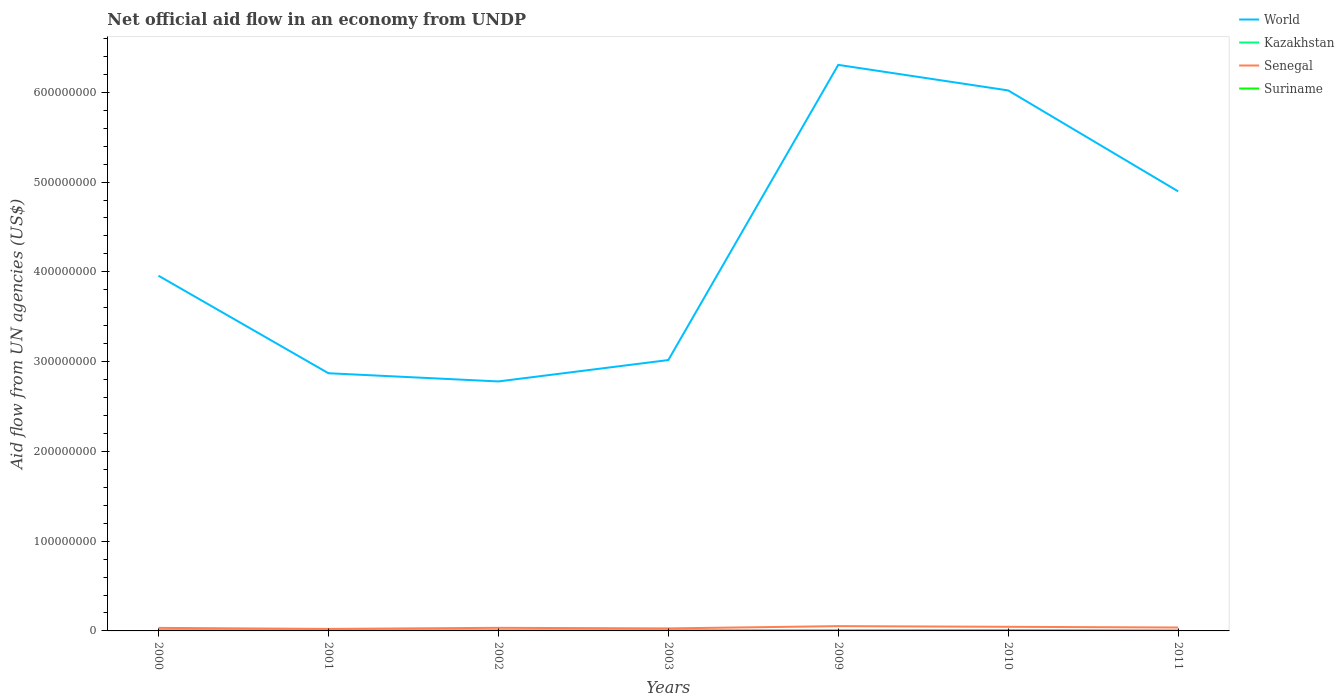In which year was the net official aid flow in Senegal maximum?
Your answer should be compact. 2001. What is the difference between the highest and the second highest net official aid flow in Suriname?
Your answer should be very brief. 4.20e+05. What is the difference between the highest and the lowest net official aid flow in World?
Your answer should be very brief. 3. How many lines are there?
Provide a succinct answer. 4. How many years are there in the graph?
Offer a terse response. 7. What is the difference between two consecutive major ticks on the Y-axis?
Provide a succinct answer. 1.00e+08. Are the values on the major ticks of Y-axis written in scientific E-notation?
Provide a short and direct response. No. Does the graph contain any zero values?
Your answer should be compact. No. How many legend labels are there?
Offer a terse response. 4. How are the legend labels stacked?
Make the answer very short. Vertical. What is the title of the graph?
Provide a succinct answer. Net official aid flow in an economy from UNDP. What is the label or title of the Y-axis?
Offer a very short reply. Aid flow from UN agencies (US$). What is the Aid flow from UN agencies (US$) in World in 2000?
Make the answer very short. 3.96e+08. What is the Aid flow from UN agencies (US$) of Kazakhstan in 2000?
Keep it short and to the point. 8.40e+05. What is the Aid flow from UN agencies (US$) in Senegal in 2000?
Your answer should be compact. 3.37e+06. What is the Aid flow from UN agencies (US$) in Suriname in 2000?
Give a very brief answer. 1.10e+05. What is the Aid flow from UN agencies (US$) of World in 2001?
Your response must be concise. 2.87e+08. What is the Aid flow from UN agencies (US$) in Kazakhstan in 2001?
Keep it short and to the point. 7.90e+05. What is the Aid flow from UN agencies (US$) of Senegal in 2001?
Offer a terse response. 2.25e+06. What is the Aid flow from UN agencies (US$) in World in 2002?
Your answer should be compact. 2.78e+08. What is the Aid flow from UN agencies (US$) in Kazakhstan in 2002?
Provide a succinct answer. 7.30e+05. What is the Aid flow from UN agencies (US$) of Senegal in 2002?
Your answer should be very brief. 3.44e+06. What is the Aid flow from UN agencies (US$) of World in 2003?
Offer a terse response. 3.02e+08. What is the Aid flow from UN agencies (US$) in Kazakhstan in 2003?
Ensure brevity in your answer.  6.40e+05. What is the Aid flow from UN agencies (US$) in Senegal in 2003?
Give a very brief answer. 2.80e+06. What is the Aid flow from UN agencies (US$) in World in 2009?
Make the answer very short. 6.31e+08. What is the Aid flow from UN agencies (US$) of Kazakhstan in 2009?
Make the answer very short. 6.80e+05. What is the Aid flow from UN agencies (US$) of Senegal in 2009?
Keep it short and to the point. 5.32e+06. What is the Aid flow from UN agencies (US$) in Suriname in 2009?
Make the answer very short. 3.20e+05. What is the Aid flow from UN agencies (US$) of World in 2010?
Provide a short and direct response. 6.02e+08. What is the Aid flow from UN agencies (US$) in Kazakhstan in 2010?
Your response must be concise. 8.30e+05. What is the Aid flow from UN agencies (US$) in Senegal in 2010?
Your response must be concise. 4.58e+06. What is the Aid flow from UN agencies (US$) in World in 2011?
Your answer should be very brief. 4.90e+08. What is the Aid flow from UN agencies (US$) in Kazakhstan in 2011?
Keep it short and to the point. 4.50e+05. What is the Aid flow from UN agencies (US$) in Senegal in 2011?
Your answer should be compact. 3.80e+06. What is the Aid flow from UN agencies (US$) in Suriname in 2011?
Ensure brevity in your answer.  2.20e+05. Across all years, what is the maximum Aid flow from UN agencies (US$) in World?
Ensure brevity in your answer.  6.31e+08. Across all years, what is the maximum Aid flow from UN agencies (US$) in Kazakhstan?
Ensure brevity in your answer.  8.40e+05. Across all years, what is the maximum Aid flow from UN agencies (US$) in Senegal?
Keep it short and to the point. 5.32e+06. Across all years, what is the maximum Aid flow from UN agencies (US$) in Suriname?
Offer a very short reply. 4.90e+05. Across all years, what is the minimum Aid flow from UN agencies (US$) of World?
Give a very brief answer. 2.78e+08. Across all years, what is the minimum Aid flow from UN agencies (US$) of Kazakhstan?
Your response must be concise. 4.50e+05. Across all years, what is the minimum Aid flow from UN agencies (US$) of Senegal?
Provide a short and direct response. 2.25e+06. Across all years, what is the minimum Aid flow from UN agencies (US$) of Suriname?
Offer a terse response. 7.00e+04. What is the total Aid flow from UN agencies (US$) of World in the graph?
Keep it short and to the point. 2.98e+09. What is the total Aid flow from UN agencies (US$) in Kazakhstan in the graph?
Offer a very short reply. 4.96e+06. What is the total Aid flow from UN agencies (US$) of Senegal in the graph?
Provide a short and direct response. 2.56e+07. What is the total Aid flow from UN agencies (US$) in Suriname in the graph?
Give a very brief answer. 1.65e+06. What is the difference between the Aid flow from UN agencies (US$) in World in 2000 and that in 2001?
Keep it short and to the point. 1.09e+08. What is the difference between the Aid flow from UN agencies (US$) of Kazakhstan in 2000 and that in 2001?
Give a very brief answer. 5.00e+04. What is the difference between the Aid flow from UN agencies (US$) in Senegal in 2000 and that in 2001?
Make the answer very short. 1.12e+06. What is the difference between the Aid flow from UN agencies (US$) in World in 2000 and that in 2002?
Your response must be concise. 1.18e+08. What is the difference between the Aid flow from UN agencies (US$) of World in 2000 and that in 2003?
Your answer should be compact. 9.40e+07. What is the difference between the Aid flow from UN agencies (US$) in Senegal in 2000 and that in 2003?
Make the answer very short. 5.70e+05. What is the difference between the Aid flow from UN agencies (US$) in World in 2000 and that in 2009?
Provide a succinct answer. -2.35e+08. What is the difference between the Aid flow from UN agencies (US$) of Kazakhstan in 2000 and that in 2009?
Make the answer very short. 1.60e+05. What is the difference between the Aid flow from UN agencies (US$) in Senegal in 2000 and that in 2009?
Your answer should be very brief. -1.95e+06. What is the difference between the Aid flow from UN agencies (US$) of Suriname in 2000 and that in 2009?
Provide a short and direct response. -2.10e+05. What is the difference between the Aid flow from UN agencies (US$) of World in 2000 and that in 2010?
Offer a very short reply. -2.06e+08. What is the difference between the Aid flow from UN agencies (US$) of Senegal in 2000 and that in 2010?
Ensure brevity in your answer.  -1.21e+06. What is the difference between the Aid flow from UN agencies (US$) in Suriname in 2000 and that in 2010?
Provide a succinct answer. -3.80e+05. What is the difference between the Aid flow from UN agencies (US$) in World in 2000 and that in 2011?
Offer a very short reply. -9.40e+07. What is the difference between the Aid flow from UN agencies (US$) of Kazakhstan in 2000 and that in 2011?
Your answer should be compact. 3.90e+05. What is the difference between the Aid flow from UN agencies (US$) in Senegal in 2000 and that in 2011?
Give a very brief answer. -4.30e+05. What is the difference between the Aid flow from UN agencies (US$) of World in 2001 and that in 2002?
Provide a short and direct response. 9.13e+06. What is the difference between the Aid flow from UN agencies (US$) of Senegal in 2001 and that in 2002?
Make the answer very short. -1.19e+06. What is the difference between the Aid flow from UN agencies (US$) of Suriname in 2001 and that in 2002?
Your answer should be very brief. 3.00e+04. What is the difference between the Aid flow from UN agencies (US$) of World in 2001 and that in 2003?
Offer a terse response. -1.47e+07. What is the difference between the Aid flow from UN agencies (US$) in Senegal in 2001 and that in 2003?
Your answer should be very brief. -5.50e+05. What is the difference between the Aid flow from UN agencies (US$) of World in 2001 and that in 2009?
Your answer should be very brief. -3.43e+08. What is the difference between the Aid flow from UN agencies (US$) of Senegal in 2001 and that in 2009?
Your answer should be compact. -3.07e+06. What is the difference between the Aid flow from UN agencies (US$) in Suriname in 2001 and that in 2009?
Provide a short and direct response. -2.20e+05. What is the difference between the Aid flow from UN agencies (US$) in World in 2001 and that in 2010?
Give a very brief answer. -3.15e+08. What is the difference between the Aid flow from UN agencies (US$) of Kazakhstan in 2001 and that in 2010?
Offer a terse response. -4.00e+04. What is the difference between the Aid flow from UN agencies (US$) in Senegal in 2001 and that in 2010?
Provide a short and direct response. -2.33e+06. What is the difference between the Aid flow from UN agencies (US$) of Suriname in 2001 and that in 2010?
Give a very brief answer. -3.90e+05. What is the difference between the Aid flow from UN agencies (US$) in World in 2001 and that in 2011?
Your answer should be compact. -2.03e+08. What is the difference between the Aid flow from UN agencies (US$) of Kazakhstan in 2001 and that in 2011?
Your answer should be compact. 3.40e+05. What is the difference between the Aid flow from UN agencies (US$) of Senegal in 2001 and that in 2011?
Offer a very short reply. -1.55e+06. What is the difference between the Aid flow from UN agencies (US$) in World in 2002 and that in 2003?
Your response must be concise. -2.38e+07. What is the difference between the Aid flow from UN agencies (US$) in Kazakhstan in 2002 and that in 2003?
Your answer should be very brief. 9.00e+04. What is the difference between the Aid flow from UN agencies (US$) of Senegal in 2002 and that in 2003?
Ensure brevity in your answer.  6.40e+05. What is the difference between the Aid flow from UN agencies (US$) of Suriname in 2002 and that in 2003?
Give a very brief answer. -2.70e+05. What is the difference between the Aid flow from UN agencies (US$) of World in 2002 and that in 2009?
Offer a very short reply. -3.53e+08. What is the difference between the Aid flow from UN agencies (US$) of Kazakhstan in 2002 and that in 2009?
Make the answer very short. 5.00e+04. What is the difference between the Aid flow from UN agencies (US$) of Senegal in 2002 and that in 2009?
Ensure brevity in your answer.  -1.88e+06. What is the difference between the Aid flow from UN agencies (US$) of Suriname in 2002 and that in 2009?
Your answer should be compact. -2.50e+05. What is the difference between the Aid flow from UN agencies (US$) of World in 2002 and that in 2010?
Your answer should be very brief. -3.24e+08. What is the difference between the Aid flow from UN agencies (US$) of Senegal in 2002 and that in 2010?
Give a very brief answer. -1.14e+06. What is the difference between the Aid flow from UN agencies (US$) of Suriname in 2002 and that in 2010?
Keep it short and to the point. -4.20e+05. What is the difference between the Aid flow from UN agencies (US$) in World in 2002 and that in 2011?
Provide a short and direct response. -2.12e+08. What is the difference between the Aid flow from UN agencies (US$) in Kazakhstan in 2002 and that in 2011?
Make the answer very short. 2.80e+05. What is the difference between the Aid flow from UN agencies (US$) of Senegal in 2002 and that in 2011?
Make the answer very short. -3.60e+05. What is the difference between the Aid flow from UN agencies (US$) in Suriname in 2002 and that in 2011?
Keep it short and to the point. -1.50e+05. What is the difference between the Aid flow from UN agencies (US$) of World in 2003 and that in 2009?
Keep it short and to the point. -3.29e+08. What is the difference between the Aid flow from UN agencies (US$) in Senegal in 2003 and that in 2009?
Give a very brief answer. -2.52e+06. What is the difference between the Aid flow from UN agencies (US$) in Suriname in 2003 and that in 2009?
Make the answer very short. 2.00e+04. What is the difference between the Aid flow from UN agencies (US$) of World in 2003 and that in 2010?
Provide a succinct answer. -3.00e+08. What is the difference between the Aid flow from UN agencies (US$) in Senegal in 2003 and that in 2010?
Offer a very short reply. -1.78e+06. What is the difference between the Aid flow from UN agencies (US$) in World in 2003 and that in 2011?
Your answer should be very brief. -1.88e+08. What is the difference between the Aid flow from UN agencies (US$) in Kazakhstan in 2003 and that in 2011?
Offer a very short reply. 1.90e+05. What is the difference between the Aid flow from UN agencies (US$) in Suriname in 2003 and that in 2011?
Keep it short and to the point. 1.20e+05. What is the difference between the Aid flow from UN agencies (US$) in World in 2009 and that in 2010?
Offer a very short reply. 2.85e+07. What is the difference between the Aid flow from UN agencies (US$) of Senegal in 2009 and that in 2010?
Your answer should be very brief. 7.40e+05. What is the difference between the Aid flow from UN agencies (US$) of Suriname in 2009 and that in 2010?
Your answer should be compact. -1.70e+05. What is the difference between the Aid flow from UN agencies (US$) in World in 2009 and that in 2011?
Provide a short and direct response. 1.41e+08. What is the difference between the Aid flow from UN agencies (US$) of Kazakhstan in 2009 and that in 2011?
Your answer should be compact. 2.30e+05. What is the difference between the Aid flow from UN agencies (US$) in Senegal in 2009 and that in 2011?
Make the answer very short. 1.52e+06. What is the difference between the Aid flow from UN agencies (US$) in Suriname in 2009 and that in 2011?
Give a very brief answer. 1.00e+05. What is the difference between the Aid flow from UN agencies (US$) in World in 2010 and that in 2011?
Provide a short and direct response. 1.12e+08. What is the difference between the Aid flow from UN agencies (US$) in Senegal in 2010 and that in 2011?
Provide a succinct answer. 7.80e+05. What is the difference between the Aid flow from UN agencies (US$) of Suriname in 2010 and that in 2011?
Your response must be concise. 2.70e+05. What is the difference between the Aid flow from UN agencies (US$) of World in 2000 and the Aid flow from UN agencies (US$) of Kazakhstan in 2001?
Keep it short and to the point. 3.95e+08. What is the difference between the Aid flow from UN agencies (US$) of World in 2000 and the Aid flow from UN agencies (US$) of Senegal in 2001?
Offer a terse response. 3.93e+08. What is the difference between the Aid flow from UN agencies (US$) in World in 2000 and the Aid flow from UN agencies (US$) in Suriname in 2001?
Offer a terse response. 3.96e+08. What is the difference between the Aid flow from UN agencies (US$) in Kazakhstan in 2000 and the Aid flow from UN agencies (US$) in Senegal in 2001?
Make the answer very short. -1.41e+06. What is the difference between the Aid flow from UN agencies (US$) of Kazakhstan in 2000 and the Aid flow from UN agencies (US$) of Suriname in 2001?
Your response must be concise. 7.40e+05. What is the difference between the Aid flow from UN agencies (US$) in Senegal in 2000 and the Aid flow from UN agencies (US$) in Suriname in 2001?
Give a very brief answer. 3.27e+06. What is the difference between the Aid flow from UN agencies (US$) of World in 2000 and the Aid flow from UN agencies (US$) of Kazakhstan in 2002?
Make the answer very short. 3.95e+08. What is the difference between the Aid flow from UN agencies (US$) in World in 2000 and the Aid flow from UN agencies (US$) in Senegal in 2002?
Offer a very short reply. 3.92e+08. What is the difference between the Aid flow from UN agencies (US$) in World in 2000 and the Aid flow from UN agencies (US$) in Suriname in 2002?
Ensure brevity in your answer.  3.96e+08. What is the difference between the Aid flow from UN agencies (US$) in Kazakhstan in 2000 and the Aid flow from UN agencies (US$) in Senegal in 2002?
Your answer should be compact. -2.60e+06. What is the difference between the Aid flow from UN agencies (US$) of Kazakhstan in 2000 and the Aid flow from UN agencies (US$) of Suriname in 2002?
Offer a terse response. 7.70e+05. What is the difference between the Aid flow from UN agencies (US$) in Senegal in 2000 and the Aid flow from UN agencies (US$) in Suriname in 2002?
Make the answer very short. 3.30e+06. What is the difference between the Aid flow from UN agencies (US$) in World in 2000 and the Aid flow from UN agencies (US$) in Kazakhstan in 2003?
Provide a short and direct response. 3.95e+08. What is the difference between the Aid flow from UN agencies (US$) in World in 2000 and the Aid flow from UN agencies (US$) in Senegal in 2003?
Offer a very short reply. 3.93e+08. What is the difference between the Aid flow from UN agencies (US$) in World in 2000 and the Aid flow from UN agencies (US$) in Suriname in 2003?
Provide a succinct answer. 3.95e+08. What is the difference between the Aid flow from UN agencies (US$) in Kazakhstan in 2000 and the Aid flow from UN agencies (US$) in Senegal in 2003?
Provide a short and direct response. -1.96e+06. What is the difference between the Aid flow from UN agencies (US$) of Senegal in 2000 and the Aid flow from UN agencies (US$) of Suriname in 2003?
Give a very brief answer. 3.03e+06. What is the difference between the Aid flow from UN agencies (US$) of World in 2000 and the Aid flow from UN agencies (US$) of Kazakhstan in 2009?
Your answer should be very brief. 3.95e+08. What is the difference between the Aid flow from UN agencies (US$) of World in 2000 and the Aid flow from UN agencies (US$) of Senegal in 2009?
Your answer should be compact. 3.90e+08. What is the difference between the Aid flow from UN agencies (US$) of World in 2000 and the Aid flow from UN agencies (US$) of Suriname in 2009?
Ensure brevity in your answer.  3.95e+08. What is the difference between the Aid flow from UN agencies (US$) of Kazakhstan in 2000 and the Aid flow from UN agencies (US$) of Senegal in 2009?
Make the answer very short. -4.48e+06. What is the difference between the Aid flow from UN agencies (US$) of Kazakhstan in 2000 and the Aid flow from UN agencies (US$) of Suriname in 2009?
Provide a short and direct response. 5.20e+05. What is the difference between the Aid flow from UN agencies (US$) in Senegal in 2000 and the Aid flow from UN agencies (US$) in Suriname in 2009?
Offer a terse response. 3.05e+06. What is the difference between the Aid flow from UN agencies (US$) in World in 2000 and the Aid flow from UN agencies (US$) in Kazakhstan in 2010?
Your answer should be compact. 3.95e+08. What is the difference between the Aid flow from UN agencies (US$) of World in 2000 and the Aid flow from UN agencies (US$) of Senegal in 2010?
Your answer should be very brief. 3.91e+08. What is the difference between the Aid flow from UN agencies (US$) of World in 2000 and the Aid flow from UN agencies (US$) of Suriname in 2010?
Your response must be concise. 3.95e+08. What is the difference between the Aid flow from UN agencies (US$) of Kazakhstan in 2000 and the Aid flow from UN agencies (US$) of Senegal in 2010?
Your response must be concise. -3.74e+06. What is the difference between the Aid flow from UN agencies (US$) of Senegal in 2000 and the Aid flow from UN agencies (US$) of Suriname in 2010?
Offer a very short reply. 2.88e+06. What is the difference between the Aid flow from UN agencies (US$) of World in 2000 and the Aid flow from UN agencies (US$) of Kazakhstan in 2011?
Offer a terse response. 3.95e+08. What is the difference between the Aid flow from UN agencies (US$) in World in 2000 and the Aid flow from UN agencies (US$) in Senegal in 2011?
Provide a short and direct response. 3.92e+08. What is the difference between the Aid flow from UN agencies (US$) in World in 2000 and the Aid flow from UN agencies (US$) in Suriname in 2011?
Your response must be concise. 3.95e+08. What is the difference between the Aid flow from UN agencies (US$) of Kazakhstan in 2000 and the Aid flow from UN agencies (US$) of Senegal in 2011?
Ensure brevity in your answer.  -2.96e+06. What is the difference between the Aid flow from UN agencies (US$) in Kazakhstan in 2000 and the Aid flow from UN agencies (US$) in Suriname in 2011?
Your response must be concise. 6.20e+05. What is the difference between the Aid flow from UN agencies (US$) in Senegal in 2000 and the Aid flow from UN agencies (US$) in Suriname in 2011?
Provide a succinct answer. 3.15e+06. What is the difference between the Aid flow from UN agencies (US$) in World in 2001 and the Aid flow from UN agencies (US$) in Kazakhstan in 2002?
Give a very brief answer. 2.86e+08. What is the difference between the Aid flow from UN agencies (US$) in World in 2001 and the Aid flow from UN agencies (US$) in Senegal in 2002?
Keep it short and to the point. 2.84e+08. What is the difference between the Aid flow from UN agencies (US$) in World in 2001 and the Aid flow from UN agencies (US$) in Suriname in 2002?
Give a very brief answer. 2.87e+08. What is the difference between the Aid flow from UN agencies (US$) of Kazakhstan in 2001 and the Aid flow from UN agencies (US$) of Senegal in 2002?
Offer a very short reply. -2.65e+06. What is the difference between the Aid flow from UN agencies (US$) in Kazakhstan in 2001 and the Aid flow from UN agencies (US$) in Suriname in 2002?
Your answer should be compact. 7.20e+05. What is the difference between the Aid flow from UN agencies (US$) of Senegal in 2001 and the Aid flow from UN agencies (US$) of Suriname in 2002?
Provide a short and direct response. 2.18e+06. What is the difference between the Aid flow from UN agencies (US$) in World in 2001 and the Aid flow from UN agencies (US$) in Kazakhstan in 2003?
Provide a succinct answer. 2.86e+08. What is the difference between the Aid flow from UN agencies (US$) of World in 2001 and the Aid flow from UN agencies (US$) of Senegal in 2003?
Your response must be concise. 2.84e+08. What is the difference between the Aid flow from UN agencies (US$) of World in 2001 and the Aid flow from UN agencies (US$) of Suriname in 2003?
Ensure brevity in your answer.  2.87e+08. What is the difference between the Aid flow from UN agencies (US$) in Kazakhstan in 2001 and the Aid flow from UN agencies (US$) in Senegal in 2003?
Offer a terse response. -2.01e+06. What is the difference between the Aid flow from UN agencies (US$) in Senegal in 2001 and the Aid flow from UN agencies (US$) in Suriname in 2003?
Ensure brevity in your answer.  1.91e+06. What is the difference between the Aid flow from UN agencies (US$) of World in 2001 and the Aid flow from UN agencies (US$) of Kazakhstan in 2009?
Ensure brevity in your answer.  2.86e+08. What is the difference between the Aid flow from UN agencies (US$) in World in 2001 and the Aid flow from UN agencies (US$) in Senegal in 2009?
Your answer should be very brief. 2.82e+08. What is the difference between the Aid flow from UN agencies (US$) of World in 2001 and the Aid flow from UN agencies (US$) of Suriname in 2009?
Keep it short and to the point. 2.87e+08. What is the difference between the Aid flow from UN agencies (US$) of Kazakhstan in 2001 and the Aid flow from UN agencies (US$) of Senegal in 2009?
Ensure brevity in your answer.  -4.53e+06. What is the difference between the Aid flow from UN agencies (US$) of Kazakhstan in 2001 and the Aid flow from UN agencies (US$) of Suriname in 2009?
Keep it short and to the point. 4.70e+05. What is the difference between the Aid flow from UN agencies (US$) in Senegal in 2001 and the Aid flow from UN agencies (US$) in Suriname in 2009?
Make the answer very short. 1.93e+06. What is the difference between the Aid flow from UN agencies (US$) of World in 2001 and the Aid flow from UN agencies (US$) of Kazakhstan in 2010?
Provide a succinct answer. 2.86e+08. What is the difference between the Aid flow from UN agencies (US$) in World in 2001 and the Aid flow from UN agencies (US$) in Senegal in 2010?
Provide a short and direct response. 2.82e+08. What is the difference between the Aid flow from UN agencies (US$) in World in 2001 and the Aid flow from UN agencies (US$) in Suriname in 2010?
Provide a succinct answer. 2.87e+08. What is the difference between the Aid flow from UN agencies (US$) in Kazakhstan in 2001 and the Aid flow from UN agencies (US$) in Senegal in 2010?
Keep it short and to the point. -3.79e+06. What is the difference between the Aid flow from UN agencies (US$) in Senegal in 2001 and the Aid flow from UN agencies (US$) in Suriname in 2010?
Ensure brevity in your answer.  1.76e+06. What is the difference between the Aid flow from UN agencies (US$) of World in 2001 and the Aid flow from UN agencies (US$) of Kazakhstan in 2011?
Give a very brief answer. 2.87e+08. What is the difference between the Aid flow from UN agencies (US$) of World in 2001 and the Aid flow from UN agencies (US$) of Senegal in 2011?
Make the answer very short. 2.83e+08. What is the difference between the Aid flow from UN agencies (US$) of World in 2001 and the Aid flow from UN agencies (US$) of Suriname in 2011?
Keep it short and to the point. 2.87e+08. What is the difference between the Aid flow from UN agencies (US$) of Kazakhstan in 2001 and the Aid flow from UN agencies (US$) of Senegal in 2011?
Provide a succinct answer. -3.01e+06. What is the difference between the Aid flow from UN agencies (US$) of Kazakhstan in 2001 and the Aid flow from UN agencies (US$) of Suriname in 2011?
Your response must be concise. 5.70e+05. What is the difference between the Aid flow from UN agencies (US$) of Senegal in 2001 and the Aid flow from UN agencies (US$) of Suriname in 2011?
Your answer should be very brief. 2.03e+06. What is the difference between the Aid flow from UN agencies (US$) of World in 2002 and the Aid flow from UN agencies (US$) of Kazakhstan in 2003?
Ensure brevity in your answer.  2.77e+08. What is the difference between the Aid flow from UN agencies (US$) in World in 2002 and the Aid flow from UN agencies (US$) in Senegal in 2003?
Provide a short and direct response. 2.75e+08. What is the difference between the Aid flow from UN agencies (US$) in World in 2002 and the Aid flow from UN agencies (US$) in Suriname in 2003?
Offer a terse response. 2.78e+08. What is the difference between the Aid flow from UN agencies (US$) in Kazakhstan in 2002 and the Aid flow from UN agencies (US$) in Senegal in 2003?
Your answer should be very brief. -2.07e+06. What is the difference between the Aid flow from UN agencies (US$) in Senegal in 2002 and the Aid flow from UN agencies (US$) in Suriname in 2003?
Make the answer very short. 3.10e+06. What is the difference between the Aid flow from UN agencies (US$) in World in 2002 and the Aid flow from UN agencies (US$) in Kazakhstan in 2009?
Keep it short and to the point. 2.77e+08. What is the difference between the Aid flow from UN agencies (US$) in World in 2002 and the Aid flow from UN agencies (US$) in Senegal in 2009?
Give a very brief answer. 2.73e+08. What is the difference between the Aid flow from UN agencies (US$) of World in 2002 and the Aid flow from UN agencies (US$) of Suriname in 2009?
Make the answer very short. 2.78e+08. What is the difference between the Aid flow from UN agencies (US$) in Kazakhstan in 2002 and the Aid flow from UN agencies (US$) in Senegal in 2009?
Your response must be concise. -4.59e+06. What is the difference between the Aid flow from UN agencies (US$) in Kazakhstan in 2002 and the Aid flow from UN agencies (US$) in Suriname in 2009?
Keep it short and to the point. 4.10e+05. What is the difference between the Aid flow from UN agencies (US$) of Senegal in 2002 and the Aid flow from UN agencies (US$) of Suriname in 2009?
Your response must be concise. 3.12e+06. What is the difference between the Aid flow from UN agencies (US$) of World in 2002 and the Aid flow from UN agencies (US$) of Kazakhstan in 2010?
Your response must be concise. 2.77e+08. What is the difference between the Aid flow from UN agencies (US$) of World in 2002 and the Aid flow from UN agencies (US$) of Senegal in 2010?
Make the answer very short. 2.73e+08. What is the difference between the Aid flow from UN agencies (US$) in World in 2002 and the Aid flow from UN agencies (US$) in Suriname in 2010?
Ensure brevity in your answer.  2.77e+08. What is the difference between the Aid flow from UN agencies (US$) in Kazakhstan in 2002 and the Aid flow from UN agencies (US$) in Senegal in 2010?
Provide a succinct answer. -3.85e+06. What is the difference between the Aid flow from UN agencies (US$) in Senegal in 2002 and the Aid flow from UN agencies (US$) in Suriname in 2010?
Your response must be concise. 2.95e+06. What is the difference between the Aid flow from UN agencies (US$) in World in 2002 and the Aid flow from UN agencies (US$) in Kazakhstan in 2011?
Your response must be concise. 2.77e+08. What is the difference between the Aid flow from UN agencies (US$) in World in 2002 and the Aid flow from UN agencies (US$) in Senegal in 2011?
Ensure brevity in your answer.  2.74e+08. What is the difference between the Aid flow from UN agencies (US$) in World in 2002 and the Aid flow from UN agencies (US$) in Suriname in 2011?
Make the answer very short. 2.78e+08. What is the difference between the Aid flow from UN agencies (US$) of Kazakhstan in 2002 and the Aid flow from UN agencies (US$) of Senegal in 2011?
Keep it short and to the point. -3.07e+06. What is the difference between the Aid flow from UN agencies (US$) in Kazakhstan in 2002 and the Aid flow from UN agencies (US$) in Suriname in 2011?
Provide a short and direct response. 5.10e+05. What is the difference between the Aid flow from UN agencies (US$) of Senegal in 2002 and the Aid flow from UN agencies (US$) of Suriname in 2011?
Offer a very short reply. 3.22e+06. What is the difference between the Aid flow from UN agencies (US$) of World in 2003 and the Aid flow from UN agencies (US$) of Kazakhstan in 2009?
Provide a short and direct response. 3.01e+08. What is the difference between the Aid flow from UN agencies (US$) of World in 2003 and the Aid flow from UN agencies (US$) of Senegal in 2009?
Ensure brevity in your answer.  2.96e+08. What is the difference between the Aid flow from UN agencies (US$) of World in 2003 and the Aid flow from UN agencies (US$) of Suriname in 2009?
Make the answer very short. 3.01e+08. What is the difference between the Aid flow from UN agencies (US$) of Kazakhstan in 2003 and the Aid flow from UN agencies (US$) of Senegal in 2009?
Your answer should be compact. -4.68e+06. What is the difference between the Aid flow from UN agencies (US$) in Kazakhstan in 2003 and the Aid flow from UN agencies (US$) in Suriname in 2009?
Provide a succinct answer. 3.20e+05. What is the difference between the Aid flow from UN agencies (US$) of Senegal in 2003 and the Aid flow from UN agencies (US$) of Suriname in 2009?
Provide a succinct answer. 2.48e+06. What is the difference between the Aid flow from UN agencies (US$) of World in 2003 and the Aid flow from UN agencies (US$) of Kazakhstan in 2010?
Your response must be concise. 3.01e+08. What is the difference between the Aid flow from UN agencies (US$) of World in 2003 and the Aid flow from UN agencies (US$) of Senegal in 2010?
Keep it short and to the point. 2.97e+08. What is the difference between the Aid flow from UN agencies (US$) in World in 2003 and the Aid flow from UN agencies (US$) in Suriname in 2010?
Provide a short and direct response. 3.01e+08. What is the difference between the Aid flow from UN agencies (US$) in Kazakhstan in 2003 and the Aid flow from UN agencies (US$) in Senegal in 2010?
Offer a very short reply. -3.94e+06. What is the difference between the Aid flow from UN agencies (US$) of Kazakhstan in 2003 and the Aid flow from UN agencies (US$) of Suriname in 2010?
Make the answer very short. 1.50e+05. What is the difference between the Aid flow from UN agencies (US$) in Senegal in 2003 and the Aid flow from UN agencies (US$) in Suriname in 2010?
Provide a succinct answer. 2.31e+06. What is the difference between the Aid flow from UN agencies (US$) in World in 2003 and the Aid flow from UN agencies (US$) in Kazakhstan in 2011?
Your answer should be compact. 3.01e+08. What is the difference between the Aid flow from UN agencies (US$) in World in 2003 and the Aid flow from UN agencies (US$) in Senegal in 2011?
Make the answer very short. 2.98e+08. What is the difference between the Aid flow from UN agencies (US$) in World in 2003 and the Aid flow from UN agencies (US$) in Suriname in 2011?
Your response must be concise. 3.02e+08. What is the difference between the Aid flow from UN agencies (US$) in Kazakhstan in 2003 and the Aid flow from UN agencies (US$) in Senegal in 2011?
Your answer should be very brief. -3.16e+06. What is the difference between the Aid flow from UN agencies (US$) of Kazakhstan in 2003 and the Aid flow from UN agencies (US$) of Suriname in 2011?
Your response must be concise. 4.20e+05. What is the difference between the Aid flow from UN agencies (US$) in Senegal in 2003 and the Aid flow from UN agencies (US$) in Suriname in 2011?
Offer a terse response. 2.58e+06. What is the difference between the Aid flow from UN agencies (US$) in World in 2009 and the Aid flow from UN agencies (US$) in Kazakhstan in 2010?
Ensure brevity in your answer.  6.30e+08. What is the difference between the Aid flow from UN agencies (US$) in World in 2009 and the Aid flow from UN agencies (US$) in Senegal in 2010?
Provide a succinct answer. 6.26e+08. What is the difference between the Aid flow from UN agencies (US$) of World in 2009 and the Aid flow from UN agencies (US$) of Suriname in 2010?
Offer a terse response. 6.30e+08. What is the difference between the Aid flow from UN agencies (US$) in Kazakhstan in 2009 and the Aid flow from UN agencies (US$) in Senegal in 2010?
Make the answer very short. -3.90e+06. What is the difference between the Aid flow from UN agencies (US$) of Senegal in 2009 and the Aid flow from UN agencies (US$) of Suriname in 2010?
Offer a terse response. 4.83e+06. What is the difference between the Aid flow from UN agencies (US$) in World in 2009 and the Aid flow from UN agencies (US$) in Kazakhstan in 2011?
Provide a short and direct response. 6.30e+08. What is the difference between the Aid flow from UN agencies (US$) in World in 2009 and the Aid flow from UN agencies (US$) in Senegal in 2011?
Keep it short and to the point. 6.27e+08. What is the difference between the Aid flow from UN agencies (US$) of World in 2009 and the Aid flow from UN agencies (US$) of Suriname in 2011?
Your answer should be very brief. 6.30e+08. What is the difference between the Aid flow from UN agencies (US$) of Kazakhstan in 2009 and the Aid flow from UN agencies (US$) of Senegal in 2011?
Ensure brevity in your answer.  -3.12e+06. What is the difference between the Aid flow from UN agencies (US$) in Senegal in 2009 and the Aid flow from UN agencies (US$) in Suriname in 2011?
Your answer should be compact. 5.10e+06. What is the difference between the Aid flow from UN agencies (US$) of World in 2010 and the Aid flow from UN agencies (US$) of Kazakhstan in 2011?
Keep it short and to the point. 6.02e+08. What is the difference between the Aid flow from UN agencies (US$) of World in 2010 and the Aid flow from UN agencies (US$) of Senegal in 2011?
Offer a terse response. 5.98e+08. What is the difference between the Aid flow from UN agencies (US$) of World in 2010 and the Aid flow from UN agencies (US$) of Suriname in 2011?
Your answer should be compact. 6.02e+08. What is the difference between the Aid flow from UN agencies (US$) of Kazakhstan in 2010 and the Aid flow from UN agencies (US$) of Senegal in 2011?
Offer a terse response. -2.97e+06. What is the difference between the Aid flow from UN agencies (US$) in Senegal in 2010 and the Aid flow from UN agencies (US$) in Suriname in 2011?
Make the answer very short. 4.36e+06. What is the average Aid flow from UN agencies (US$) of World per year?
Your answer should be very brief. 4.26e+08. What is the average Aid flow from UN agencies (US$) of Kazakhstan per year?
Make the answer very short. 7.09e+05. What is the average Aid flow from UN agencies (US$) in Senegal per year?
Your answer should be very brief. 3.65e+06. What is the average Aid flow from UN agencies (US$) of Suriname per year?
Offer a terse response. 2.36e+05. In the year 2000, what is the difference between the Aid flow from UN agencies (US$) in World and Aid flow from UN agencies (US$) in Kazakhstan?
Your answer should be compact. 3.95e+08. In the year 2000, what is the difference between the Aid flow from UN agencies (US$) of World and Aid flow from UN agencies (US$) of Senegal?
Make the answer very short. 3.92e+08. In the year 2000, what is the difference between the Aid flow from UN agencies (US$) of World and Aid flow from UN agencies (US$) of Suriname?
Provide a succinct answer. 3.96e+08. In the year 2000, what is the difference between the Aid flow from UN agencies (US$) in Kazakhstan and Aid flow from UN agencies (US$) in Senegal?
Make the answer very short. -2.53e+06. In the year 2000, what is the difference between the Aid flow from UN agencies (US$) of Kazakhstan and Aid flow from UN agencies (US$) of Suriname?
Your answer should be compact. 7.30e+05. In the year 2000, what is the difference between the Aid flow from UN agencies (US$) of Senegal and Aid flow from UN agencies (US$) of Suriname?
Keep it short and to the point. 3.26e+06. In the year 2001, what is the difference between the Aid flow from UN agencies (US$) in World and Aid flow from UN agencies (US$) in Kazakhstan?
Offer a very short reply. 2.86e+08. In the year 2001, what is the difference between the Aid flow from UN agencies (US$) of World and Aid flow from UN agencies (US$) of Senegal?
Offer a very short reply. 2.85e+08. In the year 2001, what is the difference between the Aid flow from UN agencies (US$) of World and Aid flow from UN agencies (US$) of Suriname?
Your answer should be compact. 2.87e+08. In the year 2001, what is the difference between the Aid flow from UN agencies (US$) of Kazakhstan and Aid flow from UN agencies (US$) of Senegal?
Your response must be concise. -1.46e+06. In the year 2001, what is the difference between the Aid flow from UN agencies (US$) in Kazakhstan and Aid flow from UN agencies (US$) in Suriname?
Provide a succinct answer. 6.90e+05. In the year 2001, what is the difference between the Aid flow from UN agencies (US$) in Senegal and Aid flow from UN agencies (US$) in Suriname?
Provide a succinct answer. 2.15e+06. In the year 2002, what is the difference between the Aid flow from UN agencies (US$) of World and Aid flow from UN agencies (US$) of Kazakhstan?
Provide a short and direct response. 2.77e+08. In the year 2002, what is the difference between the Aid flow from UN agencies (US$) of World and Aid flow from UN agencies (US$) of Senegal?
Offer a terse response. 2.74e+08. In the year 2002, what is the difference between the Aid flow from UN agencies (US$) of World and Aid flow from UN agencies (US$) of Suriname?
Keep it short and to the point. 2.78e+08. In the year 2002, what is the difference between the Aid flow from UN agencies (US$) in Kazakhstan and Aid flow from UN agencies (US$) in Senegal?
Your answer should be very brief. -2.71e+06. In the year 2002, what is the difference between the Aid flow from UN agencies (US$) of Kazakhstan and Aid flow from UN agencies (US$) of Suriname?
Give a very brief answer. 6.60e+05. In the year 2002, what is the difference between the Aid flow from UN agencies (US$) of Senegal and Aid flow from UN agencies (US$) of Suriname?
Ensure brevity in your answer.  3.37e+06. In the year 2003, what is the difference between the Aid flow from UN agencies (US$) in World and Aid flow from UN agencies (US$) in Kazakhstan?
Provide a short and direct response. 3.01e+08. In the year 2003, what is the difference between the Aid flow from UN agencies (US$) in World and Aid flow from UN agencies (US$) in Senegal?
Provide a short and direct response. 2.99e+08. In the year 2003, what is the difference between the Aid flow from UN agencies (US$) in World and Aid flow from UN agencies (US$) in Suriname?
Your response must be concise. 3.01e+08. In the year 2003, what is the difference between the Aid flow from UN agencies (US$) in Kazakhstan and Aid flow from UN agencies (US$) in Senegal?
Your answer should be compact. -2.16e+06. In the year 2003, what is the difference between the Aid flow from UN agencies (US$) of Kazakhstan and Aid flow from UN agencies (US$) of Suriname?
Give a very brief answer. 3.00e+05. In the year 2003, what is the difference between the Aid flow from UN agencies (US$) of Senegal and Aid flow from UN agencies (US$) of Suriname?
Give a very brief answer. 2.46e+06. In the year 2009, what is the difference between the Aid flow from UN agencies (US$) of World and Aid flow from UN agencies (US$) of Kazakhstan?
Your answer should be very brief. 6.30e+08. In the year 2009, what is the difference between the Aid flow from UN agencies (US$) of World and Aid flow from UN agencies (US$) of Senegal?
Offer a very short reply. 6.25e+08. In the year 2009, what is the difference between the Aid flow from UN agencies (US$) in World and Aid flow from UN agencies (US$) in Suriname?
Offer a terse response. 6.30e+08. In the year 2009, what is the difference between the Aid flow from UN agencies (US$) in Kazakhstan and Aid flow from UN agencies (US$) in Senegal?
Your response must be concise. -4.64e+06. In the year 2009, what is the difference between the Aid flow from UN agencies (US$) in Kazakhstan and Aid flow from UN agencies (US$) in Suriname?
Your answer should be compact. 3.60e+05. In the year 2009, what is the difference between the Aid flow from UN agencies (US$) of Senegal and Aid flow from UN agencies (US$) of Suriname?
Give a very brief answer. 5.00e+06. In the year 2010, what is the difference between the Aid flow from UN agencies (US$) of World and Aid flow from UN agencies (US$) of Kazakhstan?
Your answer should be compact. 6.01e+08. In the year 2010, what is the difference between the Aid flow from UN agencies (US$) in World and Aid flow from UN agencies (US$) in Senegal?
Provide a short and direct response. 5.97e+08. In the year 2010, what is the difference between the Aid flow from UN agencies (US$) in World and Aid flow from UN agencies (US$) in Suriname?
Provide a succinct answer. 6.02e+08. In the year 2010, what is the difference between the Aid flow from UN agencies (US$) in Kazakhstan and Aid flow from UN agencies (US$) in Senegal?
Provide a succinct answer. -3.75e+06. In the year 2010, what is the difference between the Aid flow from UN agencies (US$) of Senegal and Aid flow from UN agencies (US$) of Suriname?
Provide a short and direct response. 4.09e+06. In the year 2011, what is the difference between the Aid flow from UN agencies (US$) of World and Aid flow from UN agencies (US$) of Kazakhstan?
Give a very brief answer. 4.89e+08. In the year 2011, what is the difference between the Aid flow from UN agencies (US$) of World and Aid flow from UN agencies (US$) of Senegal?
Your response must be concise. 4.86e+08. In the year 2011, what is the difference between the Aid flow from UN agencies (US$) in World and Aid flow from UN agencies (US$) in Suriname?
Your answer should be very brief. 4.89e+08. In the year 2011, what is the difference between the Aid flow from UN agencies (US$) of Kazakhstan and Aid flow from UN agencies (US$) of Senegal?
Ensure brevity in your answer.  -3.35e+06. In the year 2011, what is the difference between the Aid flow from UN agencies (US$) of Kazakhstan and Aid flow from UN agencies (US$) of Suriname?
Give a very brief answer. 2.30e+05. In the year 2011, what is the difference between the Aid flow from UN agencies (US$) in Senegal and Aid flow from UN agencies (US$) in Suriname?
Your answer should be compact. 3.58e+06. What is the ratio of the Aid flow from UN agencies (US$) in World in 2000 to that in 2001?
Provide a succinct answer. 1.38. What is the ratio of the Aid flow from UN agencies (US$) in Kazakhstan in 2000 to that in 2001?
Your answer should be compact. 1.06. What is the ratio of the Aid flow from UN agencies (US$) of Senegal in 2000 to that in 2001?
Make the answer very short. 1.5. What is the ratio of the Aid flow from UN agencies (US$) in World in 2000 to that in 2002?
Ensure brevity in your answer.  1.42. What is the ratio of the Aid flow from UN agencies (US$) in Kazakhstan in 2000 to that in 2002?
Your answer should be compact. 1.15. What is the ratio of the Aid flow from UN agencies (US$) of Senegal in 2000 to that in 2002?
Give a very brief answer. 0.98. What is the ratio of the Aid flow from UN agencies (US$) in Suriname in 2000 to that in 2002?
Provide a succinct answer. 1.57. What is the ratio of the Aid flow from UN agencies (US$) in World in 2000 to that in 2003?
Your response must be concise. 1.31. What is the ratio of the Aid flow from UN agencies (US$) in Kazakhstan in 2000 to that in 2003?
Your response must be concise. 1.31. What is the ratio of the Aid flow from UN agencies (US$) in Senegal in 2000 to that in 2003?
Offer a terse response. 1.2. What is the ratio of the Aid flow from UN agencies (US$) of Suriname in 2000 to that in 2003?
Your answer should be very brief. 0.32. What is the ratio of the Aid flow from UN agencies (US$) of World in 2000 to that in 2009?
Make the answer very short. 0.63. What is the ratio of the Aid flow from UN agencies (US$) of Kazakhstan in 2000 to that in 2009?
Your response must be concise. 1.24. What is the ratio of the Aid flow from UN agencies (US$) of Senegal in 2000 to that in 2009?
Ensure brevity in your answer.  0.63. What is the ratio of the Aid flow from UN agencies (US$) of Suriname in 2000 to that in 2009?
Your answer should be very brief. 0.34. What is the ratio of the Aid flow from UN agencies (US$) in World in 2000 to that in 2010?
Your answer should be very brief. 0.66. What is the ratio of the Aid flow from UN agencies (US$) in Kazakhstan in 2000 to that in 2010?
Your answer should be compact. 1.01. What is the ratio of the Aid flow from UN agencies (US$) in Senegal in 2000 to that in 2010?
Ensure brevity in your answer.  0.74. What is the ratio of the Aid flow from UN agencies (US$) of Suriname in 2000 to that in 2010?
Your response must be concise. 0.22. What is the ratio of the Aid flow from UN agencies (US$) of World in 2000 to that in 2011?
Offer a terse response. 0.81. What is the ratio of the Aid flow from UN agencies (US$) of Kazakhstan in 2000 to that in 2011?
Your response must be concise. 1.87. What is the ratio of the Aid flow from UN agencies (US$) in Senegal in 2000 to that in 2011?
Your answer should be compact. 0.89. What is the ratio of the Aid flow from UN agencies (US$) in World in 2001 to that in 2002?
Provide a succinct answer. 1.03. What is the ratio of the Aid flow from UN agencies (US$) of Kazakhstan in 2001 to that in 2002?
Your answer should be very brief. 1.08. What is the ratio of the Aid flow from UN agencies (US$) in Senegal in 2001 to that in 2002?
Your answer should be very brief. 0.65. What is the ratio of the Aid flow from UN agencies (US$) in Suriname in 2001 to that in 2002?
Your answer should be compact. 1.43. What is the ratio of the Aid flow from UN agencies (US$) of World in 2001 to that in 2003?
Make the answer very short. 0.95. What is the ratio of the Aid flow from UN agencies (US$) in Kazakhstan in 2001 to that in 2003?
Make the answer very short. 1.23. What is the ratio of the Aid flow from UN agencies (US$) of Senegal in 2001 to that in 2003?
Your response must be concise. 0.8. What is the ratio of the Aid flow from UN agencies (US$) in Suriname in 2001 to that in 2003?
Your response must be concise. 0.29. What is the ratio of the Aid flow from UN agencies (US$) of World in 2001 to that in 2009?
Ensure brevity in your answer.  0.46. What is the ratio of the Aid flow from UN agencies (US$) in Kazakhstan in 2001 to that in 2009?
Give a very brief answer. 1.16. What is the ratio of the Aid flow from UN agencies (US$) in Senegal in 2001 to that in 2009?
Your answer should be very brief. 0.42. What is the ratio of the Aid flow from UN agencies (US$) in Suriname in 2001 to that in 2009?
Your response must be concise. 0.31. What is the ratio of the Aid flow from UN agencies (US$) in World in 2001 to that in 2010?
Offer a very short reply. 0.48. What is the ratio of the Aid flow from UN agencies (US$) of Kazakhstan in 2001 to that in 2010?
Offer a terse response. 0.95. What is the ratio of the Aid flow from UN agencies (US$) in Senegal in 2001 to that in 2010?
Ensure brevity in your answer.  0.49. What is the ratio of the Aid flow from UN agencies (US$) in Suriname in 2001 to that in 2010?
Provide a short and direct response. 0.2. What is the ratio of the Aid flow from UN agencies (US$) in World in 2001 to that in 2011?
Make the answer very short. 0.59. What is the ratio of the Aid flow from UN agencies (US$) of Kazakhstan in 2001 to that in 2011?
Offer a very short reply. 1.76. What is the ratio of the Aid flow from UN agencies (US$) in Senegal in 2001 to that in 2011?
Give a very brief answer. 0.59. What is the ratio of the Aid flow from UN agencies (US$) of Suriname in 2001 to that in 2011?
Make the answer very short. 0.45. What is the ratio of the Aid flow from UN agencies (US$) of World in 2002 to that in 2003?
Provide a short and direct response. 0.92. What is the ratio of the Aid flow from UN agencies (US$) of Kazakhstan in 2002 to that in 2003?
Ensure brevity in your answer.  1.14. What is the ratio of the Aid flow from UN agencies (US$) of Senegal in 2002 to that in 2003?
Offer a very short reply. 1.23. What is the ratio of the Aid flow from UN agencies (US$) of Suriname in 2002 to that in 2003?
Your response must be concise. 0.21. What is the ratio of the Aid flow from UN agencies (US$) in World in 2002 to that in 2009?
Provide a short and direct response. 0.44. What is the ratio of the Aid flow from UN agencies (US$) in Kazakhstan in 2002 to that in 2009?
Offer a very short reply. 1.07. What is the ratio of the Aid flow from UN agencies (US$) of Senegal in 2002 to that in 2009?
Offer a very short reply. 0.65. What is the ratio of the Aid flow from UN agencies (US$) in Suriname in 2002 to that in 2009?
Keep it short and to the point. 0.22. What is the ratio of the Aid flow from UN agencies (US$) in World in 2002 to that in 2010?
Your answer should be compact. 0.46. What is the ratio of the Aid flow from UN agencies (US$) of Kazakhstan in 2002 to that in 2010?
Your answer should be compact. 0.88. What is the ratio of the Aid flow from UN agencies (US$) of Senegal in 2002 to that in 2010?
Offer a very short reply. 0.75. What is the ratio of the Aid flow from UN agencies (US$) of Suriname in 2002 to that in 2010?
Make the answer very short. 0.14. What is the ratio of the Aid flow from UN agencies (US$) in World in 2002 to that in 2011?
Provide a short and direct response. 0.57. What is the ratio of the Aid flow from UN agencies (US$) of Kazakhstan in 2002 to that in 2011?
Your answer should be compact. 1.62. What is the ratio of the Aid flow from UN agencies (US$) in Senegal in 2002 to that in 2011?
Make the answer very short. 0.91. What is the ratio of the Aid flow from UN agencies (US$) in Suriname in 2002 to that in 2011?
Offer a very short reply. 0.32. What is the ratio of the Aid flow from UN agencies (US$) in World in 2003 to that in 2009?
Offer a terse response. 0.48. What is the ratio of the Aid flow from UN agencies (US$) in Kazakhstan in 2003 to that in 2009?
Offer a very short reply. 0.94. What is the ratio of the Aid flow from UN agencies (US$) in Senegal in 2003 to that in 2009?
Offer a very short reply. 0.53. What is the ratio of the Aid flow from UN agencies (US$) in Suriname in 2003 to that in 2009?
Offer a terse response. 1.06. What is the ratio of the Aid flow from UN agencies (US$) of World in 2003 to that in 2010?
Ensure brevity in your answer.  0.5. What is the ratio of the Aid flow from UN agencies (US$) in Kazakhstan in 2003 to that in 2010?
Your answer should be compact. 0.77. What is the ratio of the Aid flow from UN agencies (US$) of Senegal in 2003 to that in 2010?
Provide a short and direct response. 0.61. What is the ratio of the Aid flow from UN agencies (US$) in Suriname in 2003 to that in 2010?
Your answer should be very brief. 0.69. What is the ratio of the Aid flow from UN agencies (US$) in World in 2003 to that in 2011?
Give a very brief answer. 0.62. What is the ratio of the Aid flow from UN agencies (US$) of Kazakhstan in 2003 to that in 2011?
Offer a very short reply. 1.42. What is the ratio of the Aid flow from UN agencies (US$) in Senegal in 2003 to that in 2011?
Your answer should be very brief. 0.74. What is the ratio of the Aid flow from UN agencies (US$) of Suriname in 2003 to that in 2011?
Provide a short and direct response. 1.55. What is the ratio of the Aid flow from UN agencies (US$) in World in 2009 to that in 2010?
Make the answer very short. 1.05. What is the ratio of the Aid flow from UN agencies (US$) of Kazakhstan in 2009 to that in 2010?
Your answer should be compact. 0.82. What is the ratio of the Aid flow from UN agencies (US$) of Senegal in 2009 to that in 2010?
Offer a terse response. 1.16. What is the ratio of the Aid flow from UN agencies (US$) in Suriname in 2009 to that in 2010?
Keep it short and to the point. 0.65. What is the ratio of the Aid flow from UN agencies (US$) of World in 2009 to that in 2011?
Your response must be concise. 1.29. What is the ratio of the Aid flow from UN agencies (US$) of Kazakhstan in 2009 to that in 2011?
Ensure brevity in your answer.  1.51. What is the ratio of the Aid flow from UN agencies (US$) of Suriname in 2009 to that in 2011?
Your answer should be very brief. 1.45. What is the ratio of the Aid flow from UN agencies (US$) in World in 2010 to that in 2011?
Keep it short and to the point. 1.23. What is the ratio of the Aid flow from UN agencies (US$) in Kazakhstan in 2010 to that in 2011?
Your answer should be very brief. 1.84. What is the ratio of the Aid flow from UN agencies (US$) of Senegal in 2010 to that in 2011?
Ensure brevity in your answer.  1.21. What is the ratio of the Aid flow from UN agencies (US$) in Suriname in 2010 to that in 2011?
Ensure brevity in your answer.  2.23. What is the difference between the highest and the second highest Aid flow from UN agencies (US$) in World?
Provide a short and direct response. 2.85e+07. What is the difference between the highest and the second highest Aid flow from UN agencies (US$) in Senegal?
Keep it short and to the point. 7.40e+05. What is the difference between the highest and the second highest Aid flow from UN agencies (US$) in Suriname?
Give a very brief answer. 1.50e+05. What is the difference between the highest and the lowest Aid flow from UN agencies (US$) in World?
Ensure brevity in your answer.  3.53e+08. What is the difference between the highest and the lowest Aid flow from UN agencies (US$) of Kazakhstan?
Your answer should be very brief. 3.90e+05. What is the difference between the highest and the lowest Aid flow from UN agencies (US$) of Senegal?
Provide a short and direct response. 3.07e+06. 